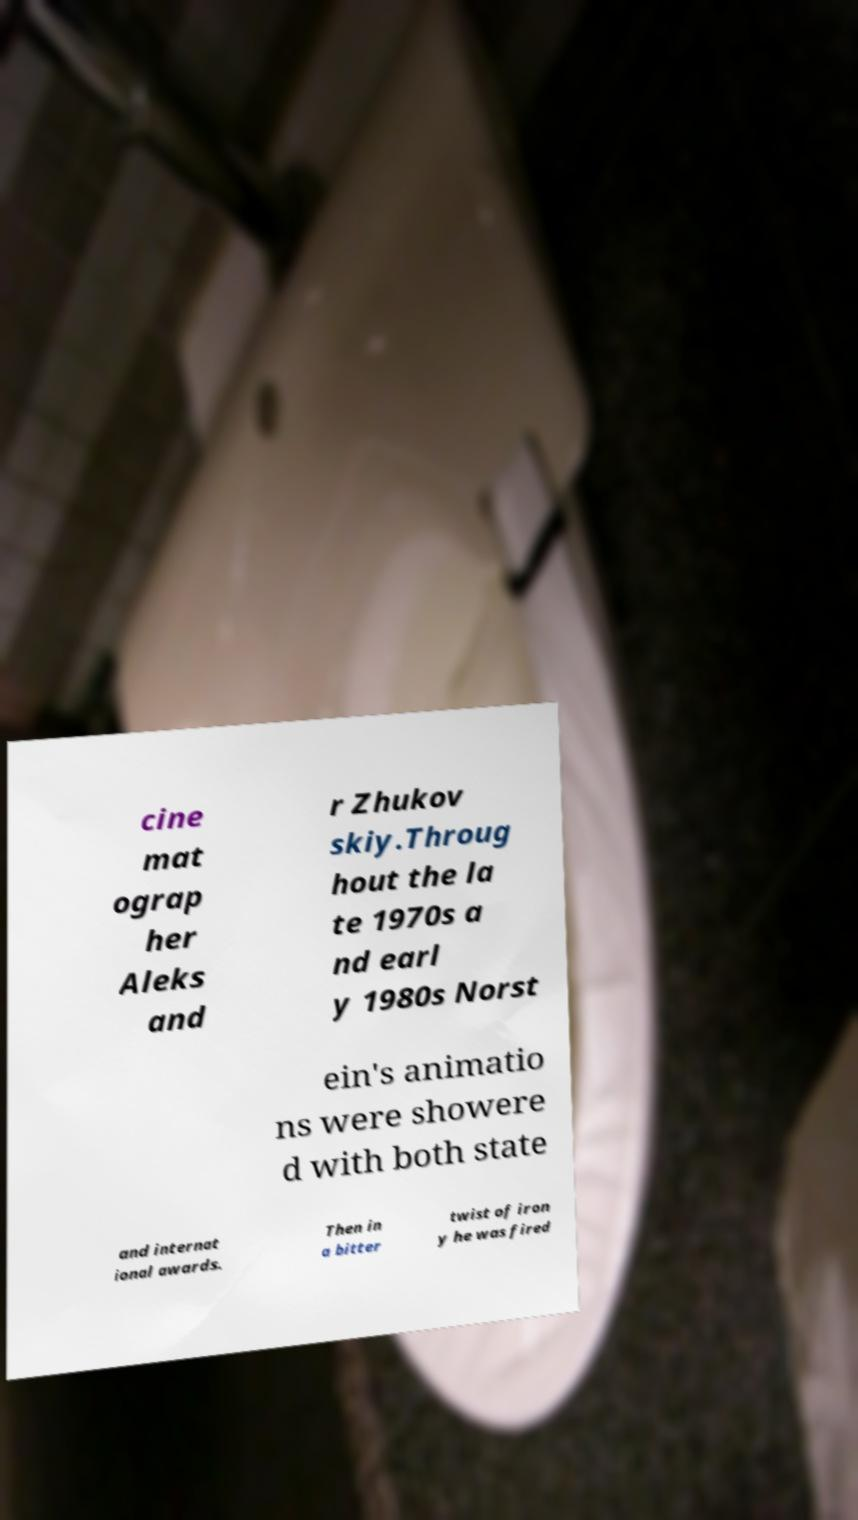What messages or text are displayed in this image? I need them in a readable, typed format. cine mat ograp her Aleks and r Zhukov skiy.Throug hout the la te 1970s a nd earl y 1980s Norst ein's animatio ns were showere d with both state and internat ional awards. Then in a bitter twist of iron y he was fired 